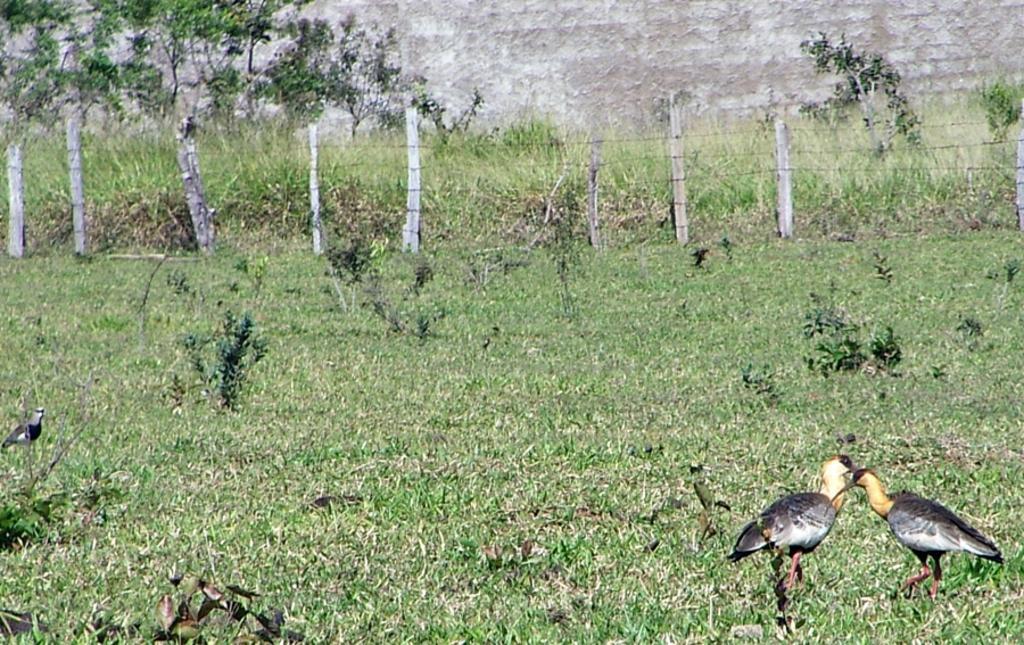Can you describe this image briefly? This picture is clicked outside. On the right corner we can see the two birds and we can see the green grass, plants, poles, wall and some other objects. 